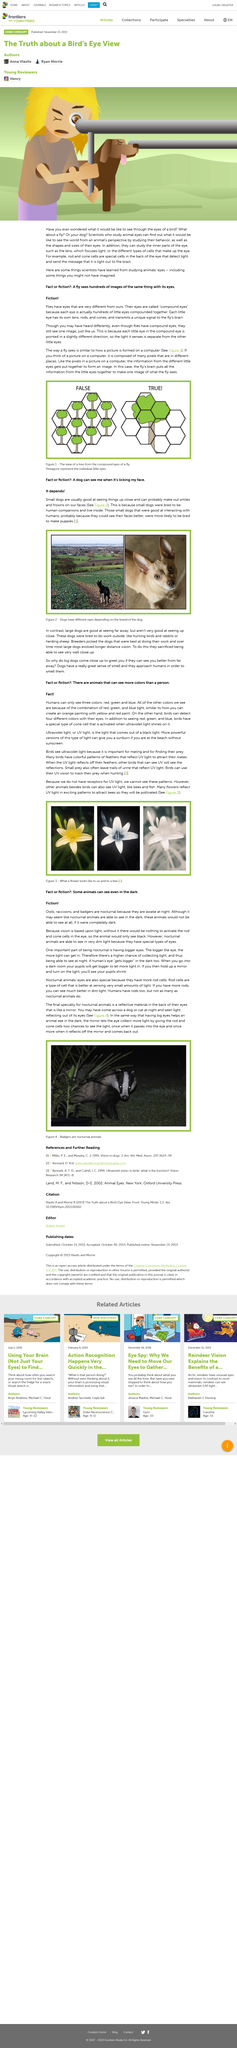Give some essential details in this illustration. The brown animal that is situated next to the person is a dog. The special cells in the back of the eye are known as rod and cone cells. Compound eyes are eyes composed of multiple individual eyes that have been combined together to form a single visual organ. The answer to the question depends. The figure with trees provides a clear answer to the question proposed in the article. 